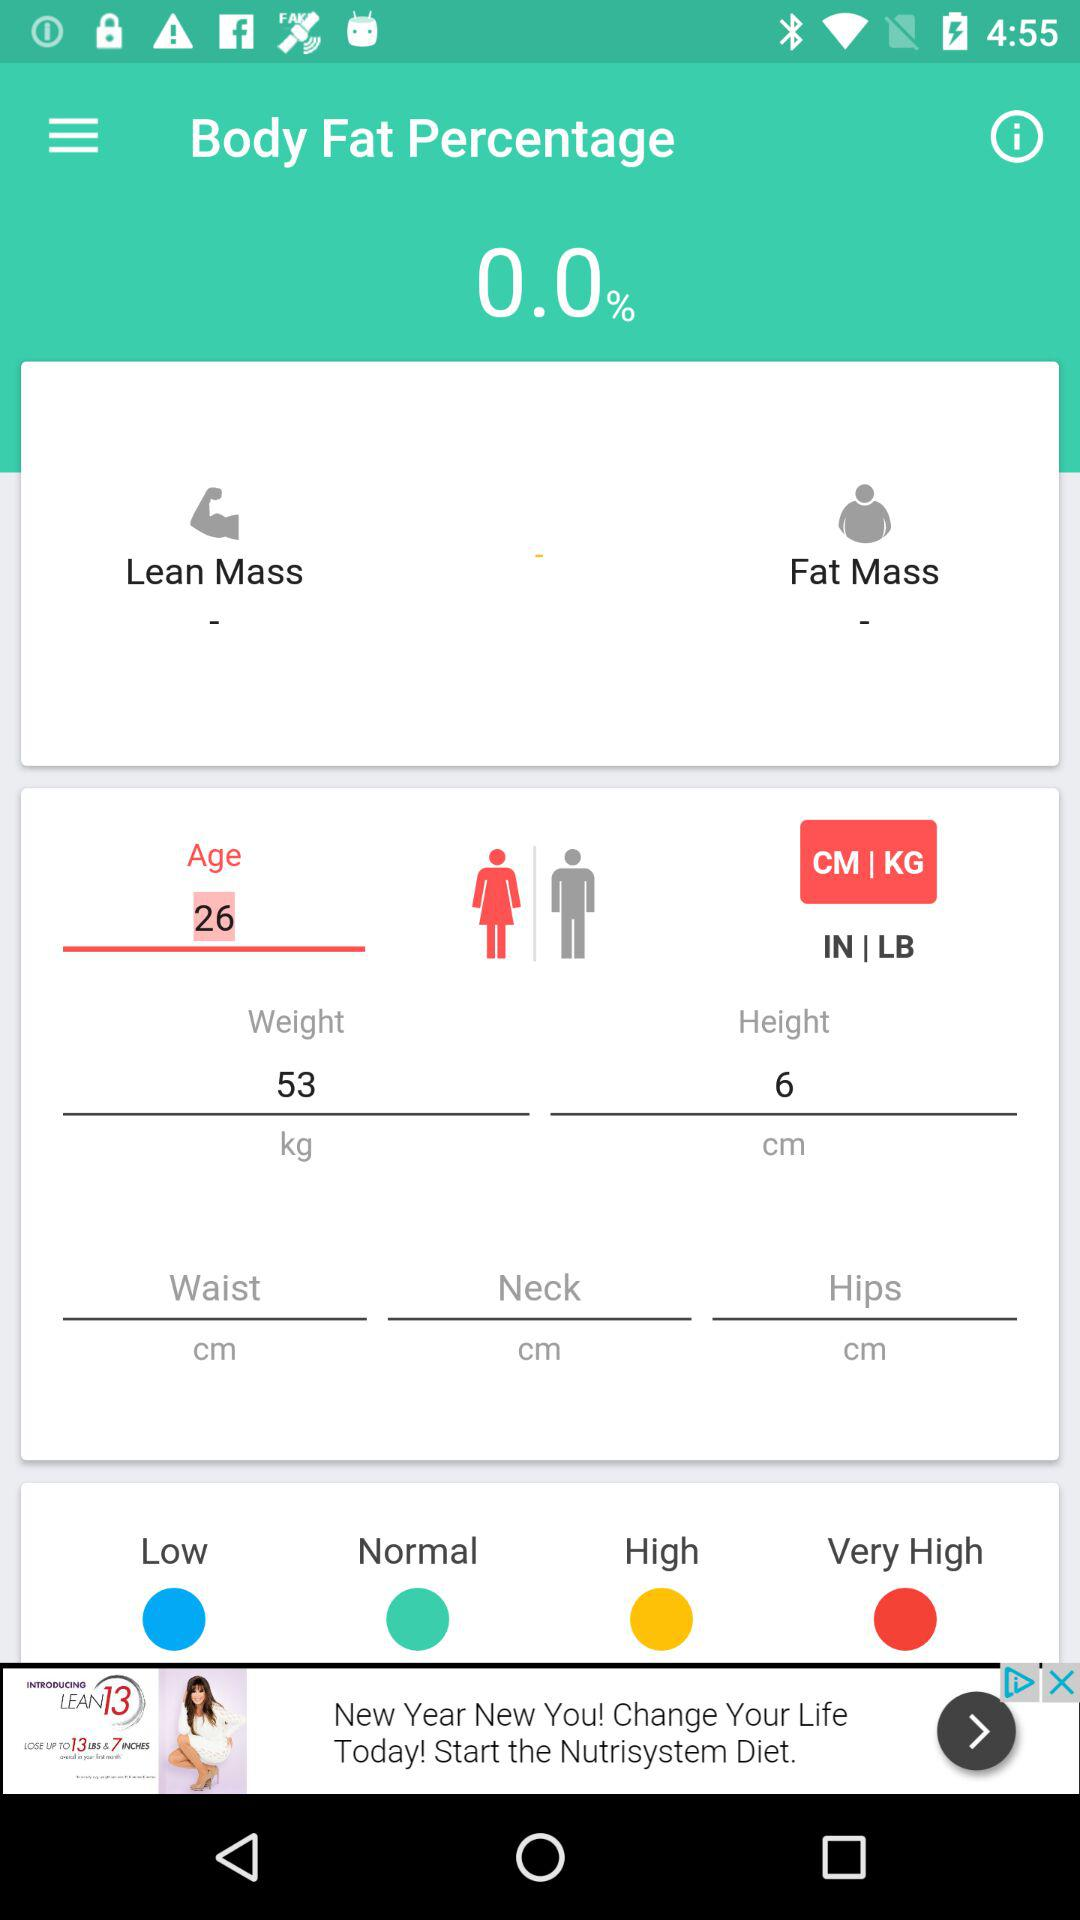What is the body fat %? The body fat percentage is 0. 